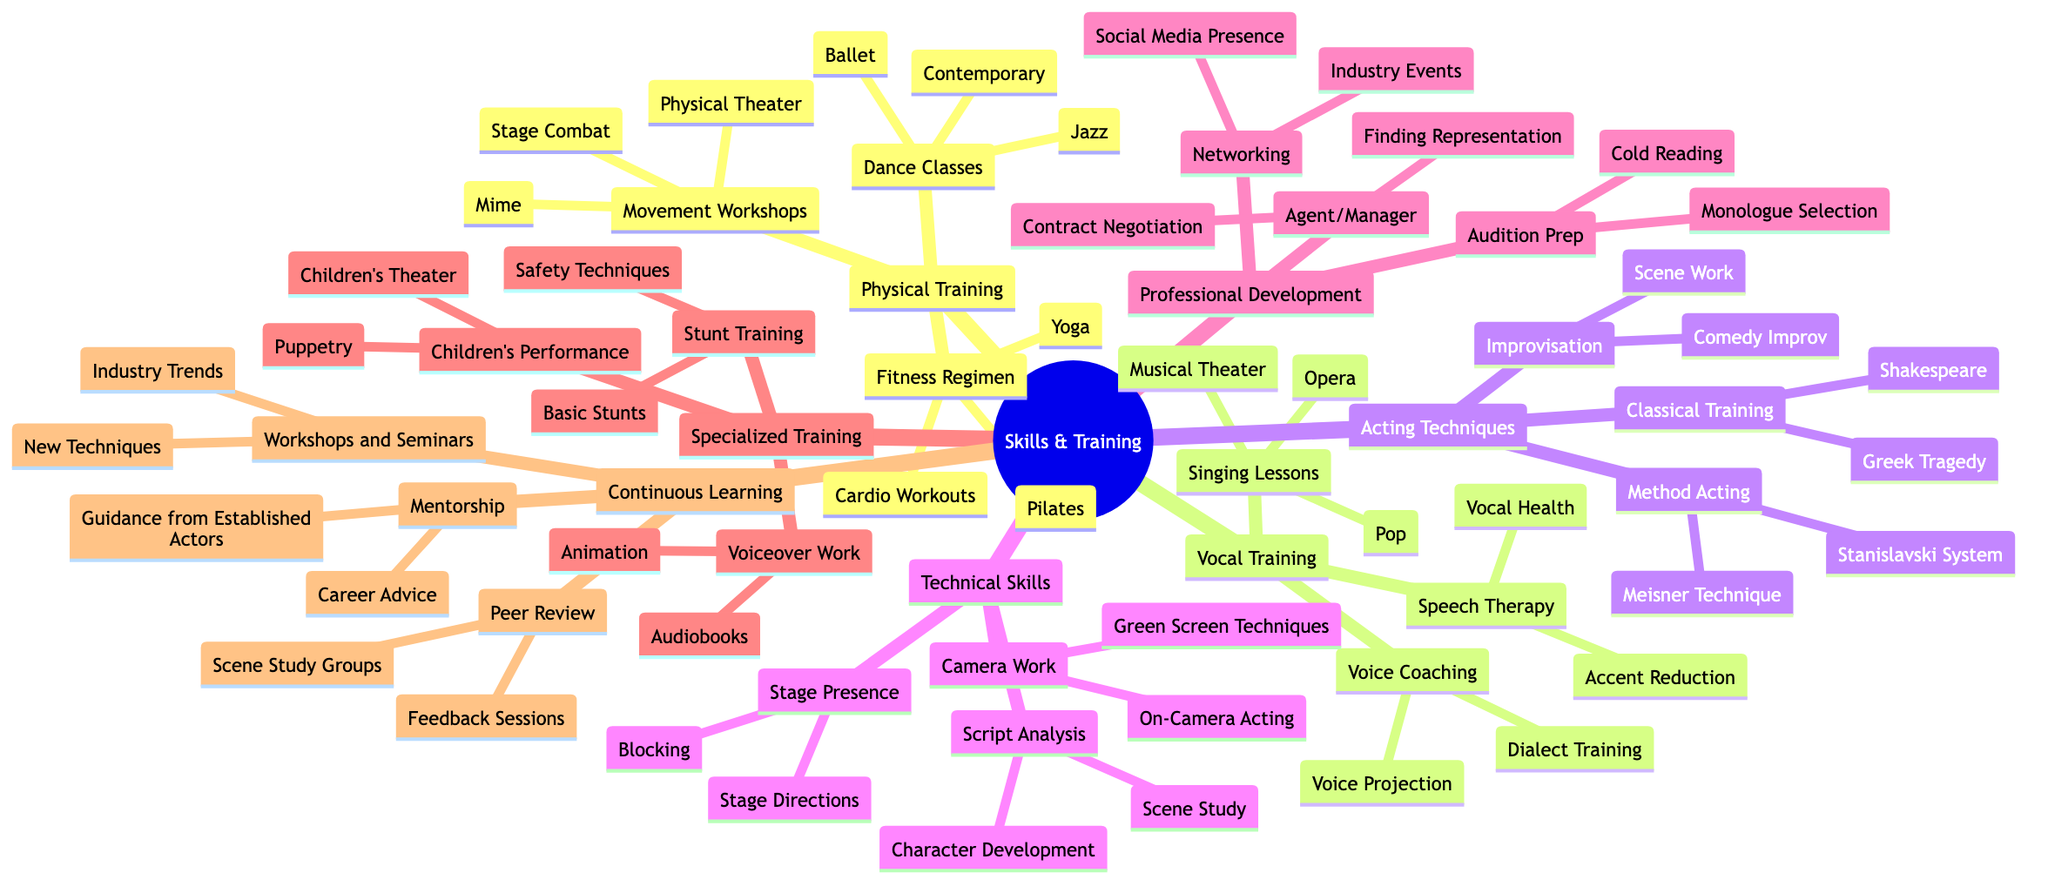What are the categories of skills in the mind map? The main categories in the mind map are listed as branches from the root node, which include Physical Training, Vocal Training, Acting Techniques, Technical Skills, Professional Development, Specialized Training, and Continuous Learning. These are easily identifiable as the first-level nodes.
Answer: Physical Training, Vocal Training, Acting Techniques, Technical Skills, Professional Development, Specialized Training, Continuous Learning How many types of training are there for Vocal Training? The Vocal Training branch has three sub-nodes: Voice Coaching, Singing Lessons, and Speech Therapy. Counting these gives us a total of three types of training under Vocal Training.
Answer: 3 What is one of the dance classes mentioned under Physical Training? Under the Physical Training node, there are three specific classes listed as Ballet, Jazz, and Contemporary. Any of these would answer the question.
Answer: Ballet What are the methods under Acting Techniques? The Acting Techniques category contains three main methods: Method Acting, Classical Training, and Improvisation, making it clear that these are the foundational techniques for acting training.
Answer: Method Acting, Classical Training, Improvisation What specialized training is provided for children's performance? In the Specialized Training node, the sub-node under Children's Performance mentions Puppetry and Children's Theater. We can reference either of these when answering the question.
Answer: Puppetry Which skills are included in Technical Skills? The Technical Skills branch consists of three elements: Camera Work, Stage Presence, and Script Analysis. Each represents a different foundational aspect of acting from a technical perspective.
Answer: Camera Work, Stage Presence, Script Analysis What type of continuous learning is related to mentorship? Under the Continuous Learning node, mentorship is categorized that focuses on providing guidance from established actors and career advice. The sub-node clearly indicates the purpose and type of this learning.
Answer: Guidance from Established Actors How many specific elements are included in Professional Development? The Professional Development node lists three specific elements: Audition Prep, Networking, and Agent/Manager. Hence, the total number of elements in this section is three.
Answer: 3 What is one of the fitness regimens included under Physical Training? Looking under Physical Training, we can find Fitness Regimen, and the sub-nodes include Yoga, Pilates, and Cardio Workouts. Mentioning any of these gives a correct answer to the question.
Answer: Yoga 